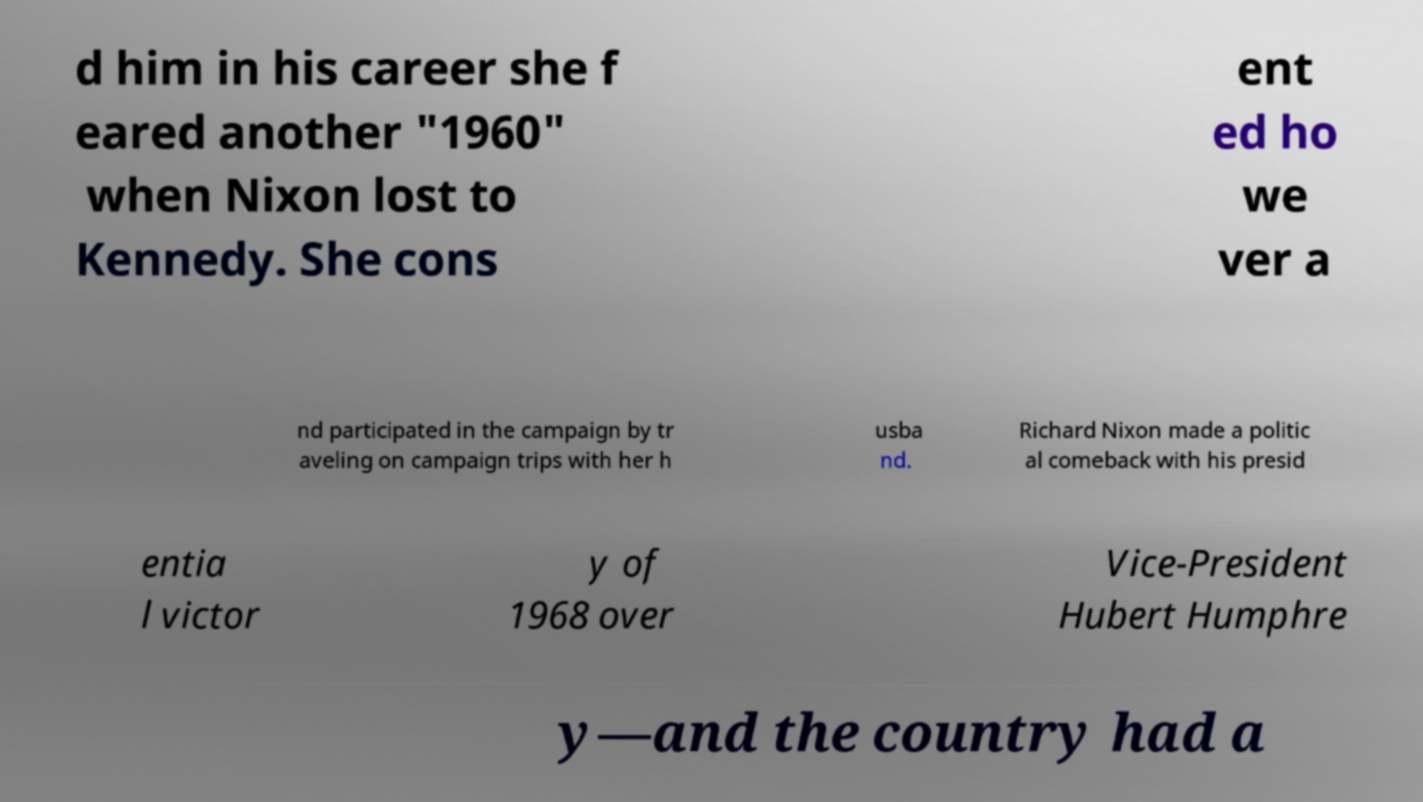There's text embedded in this image that I need extracted. Can you transcribe it verbatim? d him in his career she f eared another "1960" when Nixon lost to Kennedy. She cons ent ed ho we ver a nd participated in the campaign by tr aveling on campaign trips with her h usba nd. Richard Nixon made a politic al comeback with his presid entia l victor y of 1968 over Vice-President Hubert Humphre y—and the country had a 